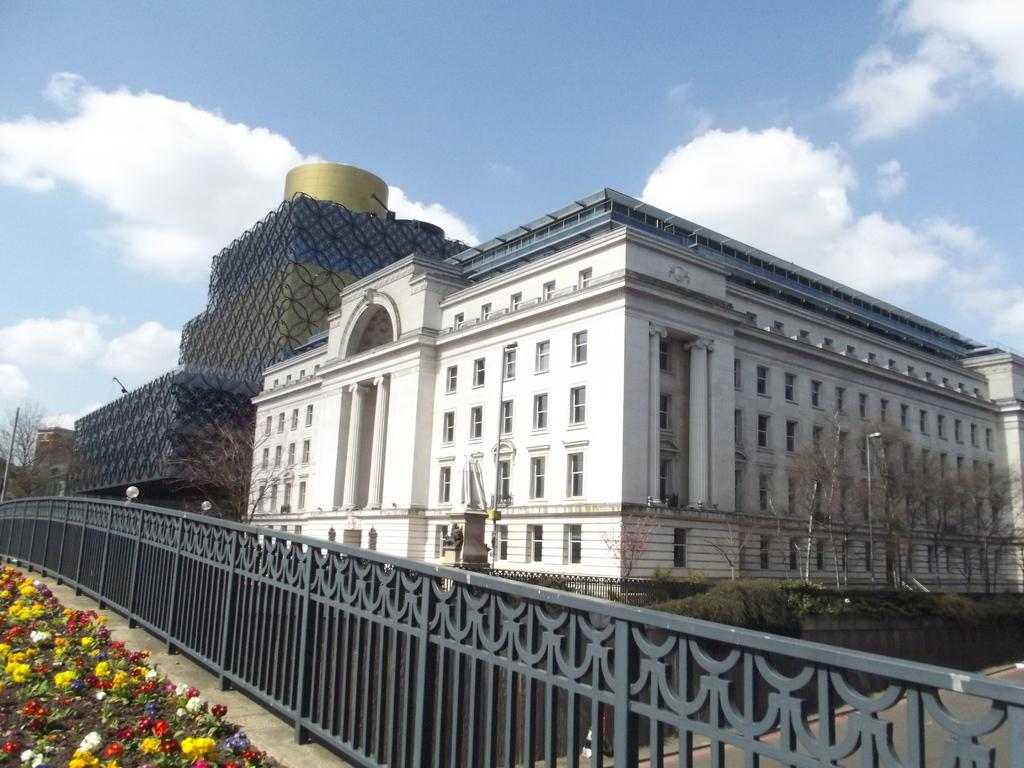What is the main structure in the center of the image? There is a building in the center of the image. What can be seen near the building? There is a railing in the image. What type of vegetation is present in the image? There are trees in the image. Where are the flower plants located in the image? The flower plants are on the left side of the image. What is visible at the top of the image? The sky is visible at the top of the image. What type of machine is used to pump water in the image? There is no machine or water pump present in the image. 